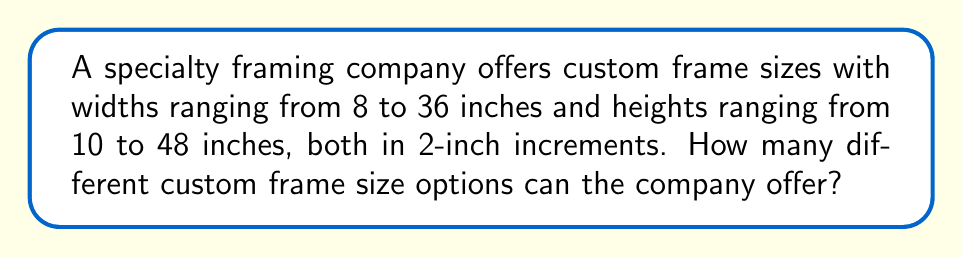Could you help me with this problem? Let's approach this step-by-step:

1) First, we need to determine the number of possible widths:
   - The range is from 8 to 36 inches, in 2-inch increments.
   - We can calculate this using the arithmetic sequence formula:
     $$ n = \frac{a_n - a_1}{d} + 1 $$
     where $n$ is the number of terms, $a_n$ is the last term, $a_1$ is the first term, and $d$ is the common difference.
   - Plugging in our values: $n = \frac{36 - 8}{2} + 1 = 15$

2) Similarly, for the heights:
   - The range is from 10 to 48 inches, in 2-inch increments.
   - Using the same formula: $n = \frac{48 - 10}{2} + 1 = 20$

3) Now, for each width, we can choose any of the available heights. This is a multiplication principle problem.

4) The total number of possible frame sizes is therefore:
   $$ 15 \times 20 = 300 $$

Thus, the company can offer 300 different custom frame size options.
Answer: 300 